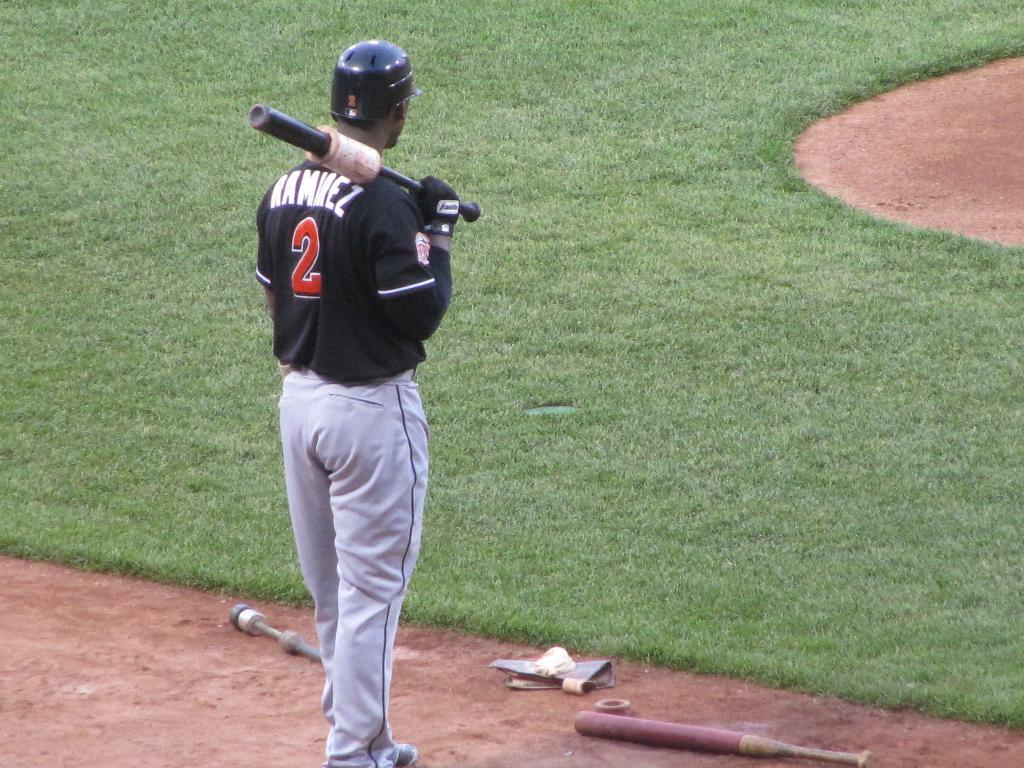<image>
Write a terse but informative summary of the picture. a person with the number 2 on the back of their jersey 